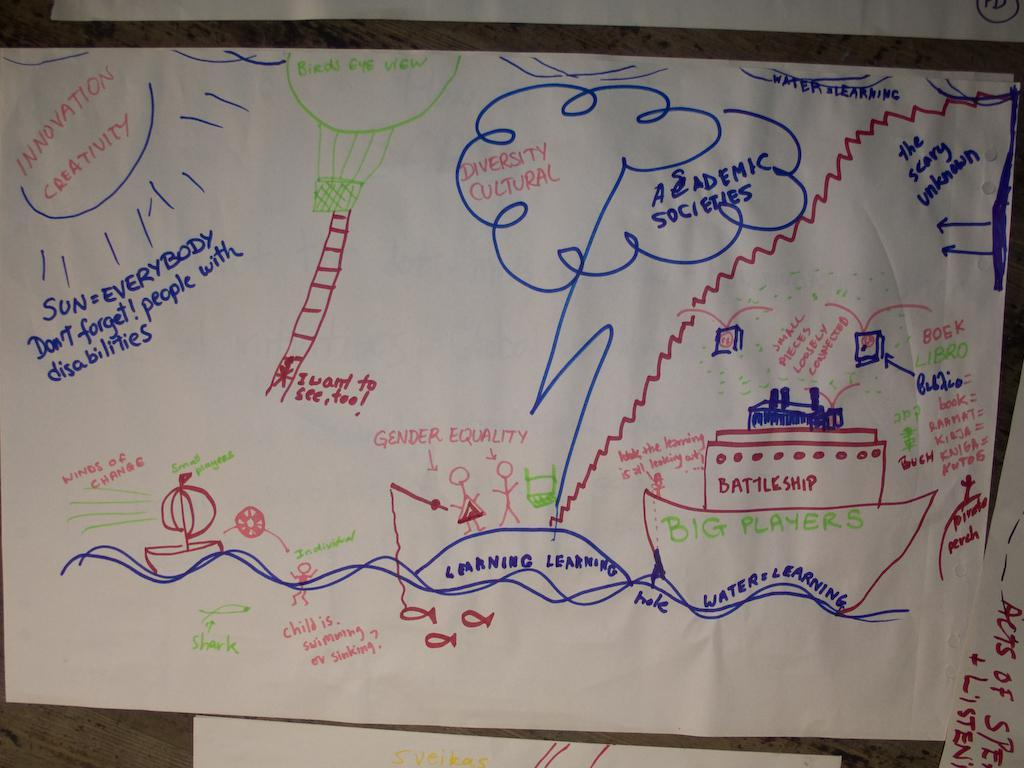<image>
Relay a brief, clear account of the picture shown. the word creativity that is on the white paper 